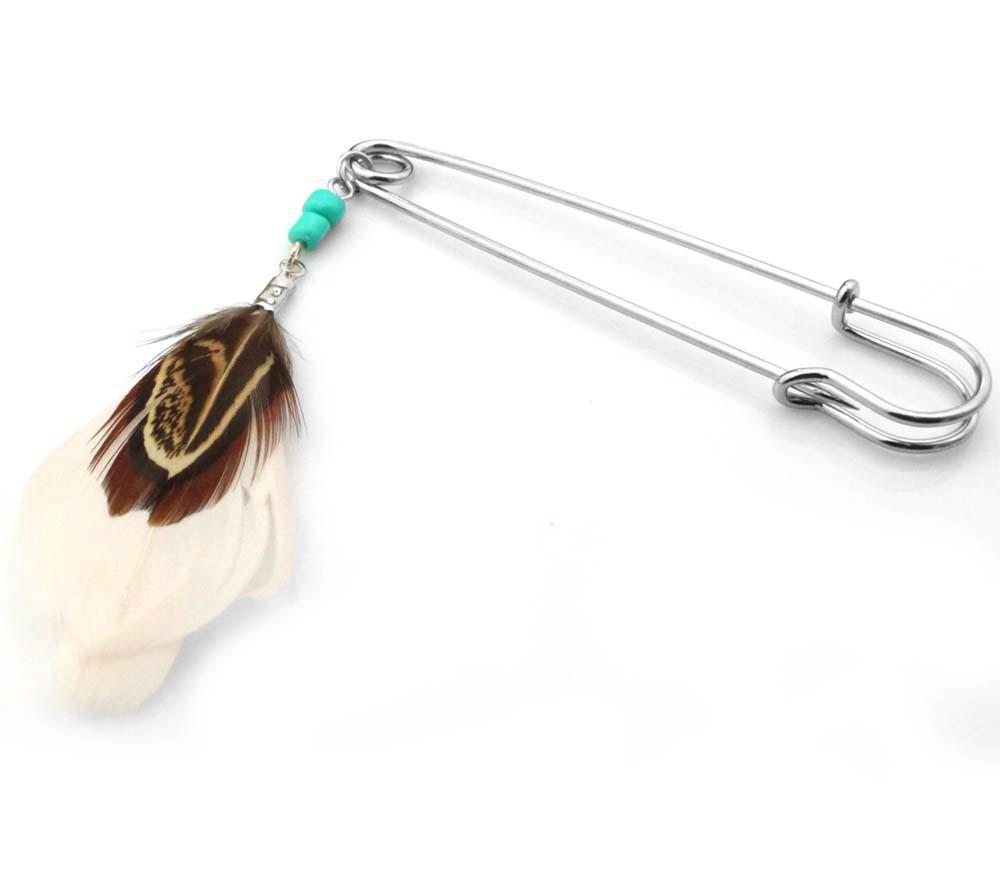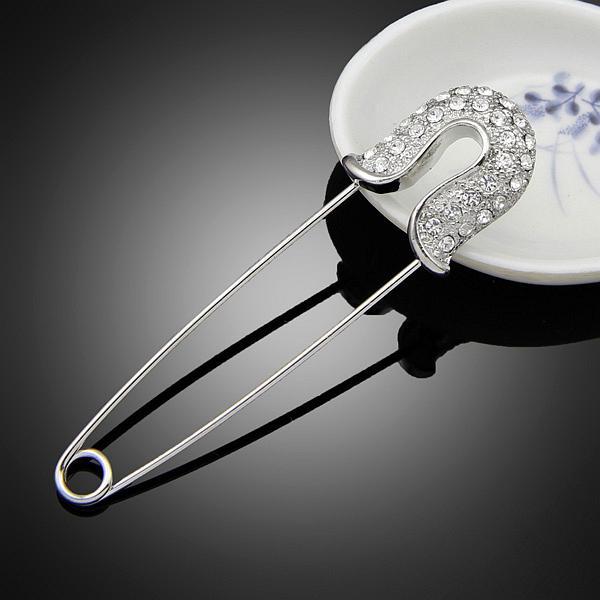The first image is the image on the left, the second image is the image on the right. Assess this claim about the two images: "There is a feather in one of the images.". Correct or not? Answer yes or no. Yes. 